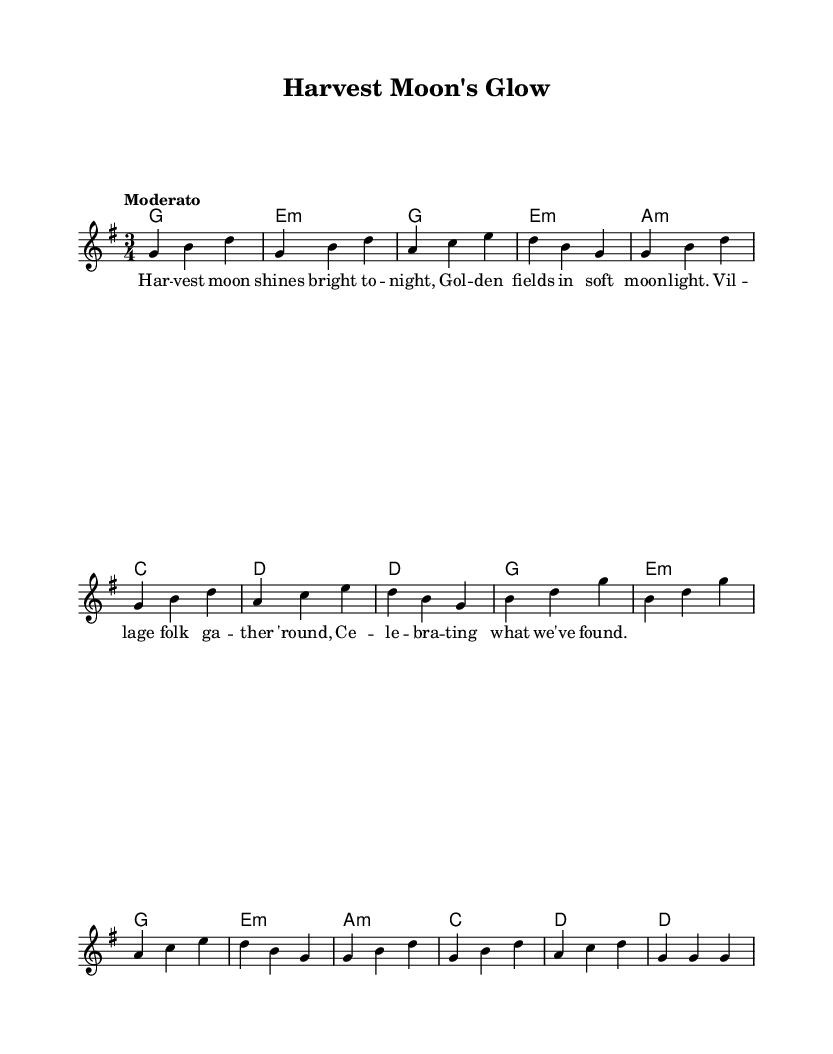What is the key signature of this music? The key signature is G major, which has one sharp (F#). This is indicated at the beginning of the staff where the key signature is shown.
Answer: G major What is the time signature of this music? The time signature is 3/4, which is indicated at the beginning of the score. This means there are three beats per measure and the quarter note gets one beat.
Answer: 3/4 What is the tempo marking of this piece? The tempo marking is "Moderato," which is typically interpreted as a moderate speed. This can be found in the tempo indication at the beginning of the sheet music.
Answer: Moderato What is the first note of the melody? The first note of the melody is G, which is indicated at the start of the melody line in the score.
Answer: G How many measures are in the melody? There are 12 measures in the melody, counted by noting the bar lines that separate each measure in the music.
Answer: 12 What type of song is "Harvest Moon's Glow"? The song is a folk song, which is characterized by its simple melodies and lyrics that often reflect rural life and traditions, as seen in the lyrics describing village gathering.
Answer: Folk What is the theme of the lyrics? The theme of the lyrics celebrates the harvest and village life, as indicated by phrases about the harvest moon and village folk gathering to celebrate. This captures the essence of rural traditions.
Answer: Harvest celebration 